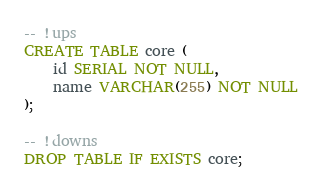<code> <loc_0><loc_0><loc_500><loc_500><_SQL_>-- !ups
CREATE TABLE core (
    id SERIAL NOT NULL,
    name VARCHAR(255) NOT NULL
);

-- !downs
DROP TABLE IF EXISTS core;</code> 